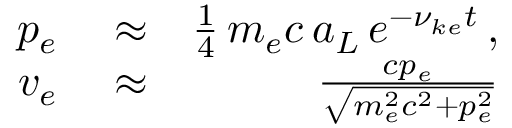Convert formula to latex. <formula><loc_0><loc_0><loc_500><loc_500>\begin{array} { r l r } { p _ { e } } & \approx } & { \frac { 1 } { 4 } \, m _ { e } c \, a _ { L } \, e ^ { - \nu _ { k e } t } \, , } \\ { v _ { e } } & \approx } & { \frac { c p _ { e } } { \sqrt { m _ { e } ^ { 2 } c ^ { 2 } + p _ { e } ^ { 2 } } } } \end{array}</formula> 